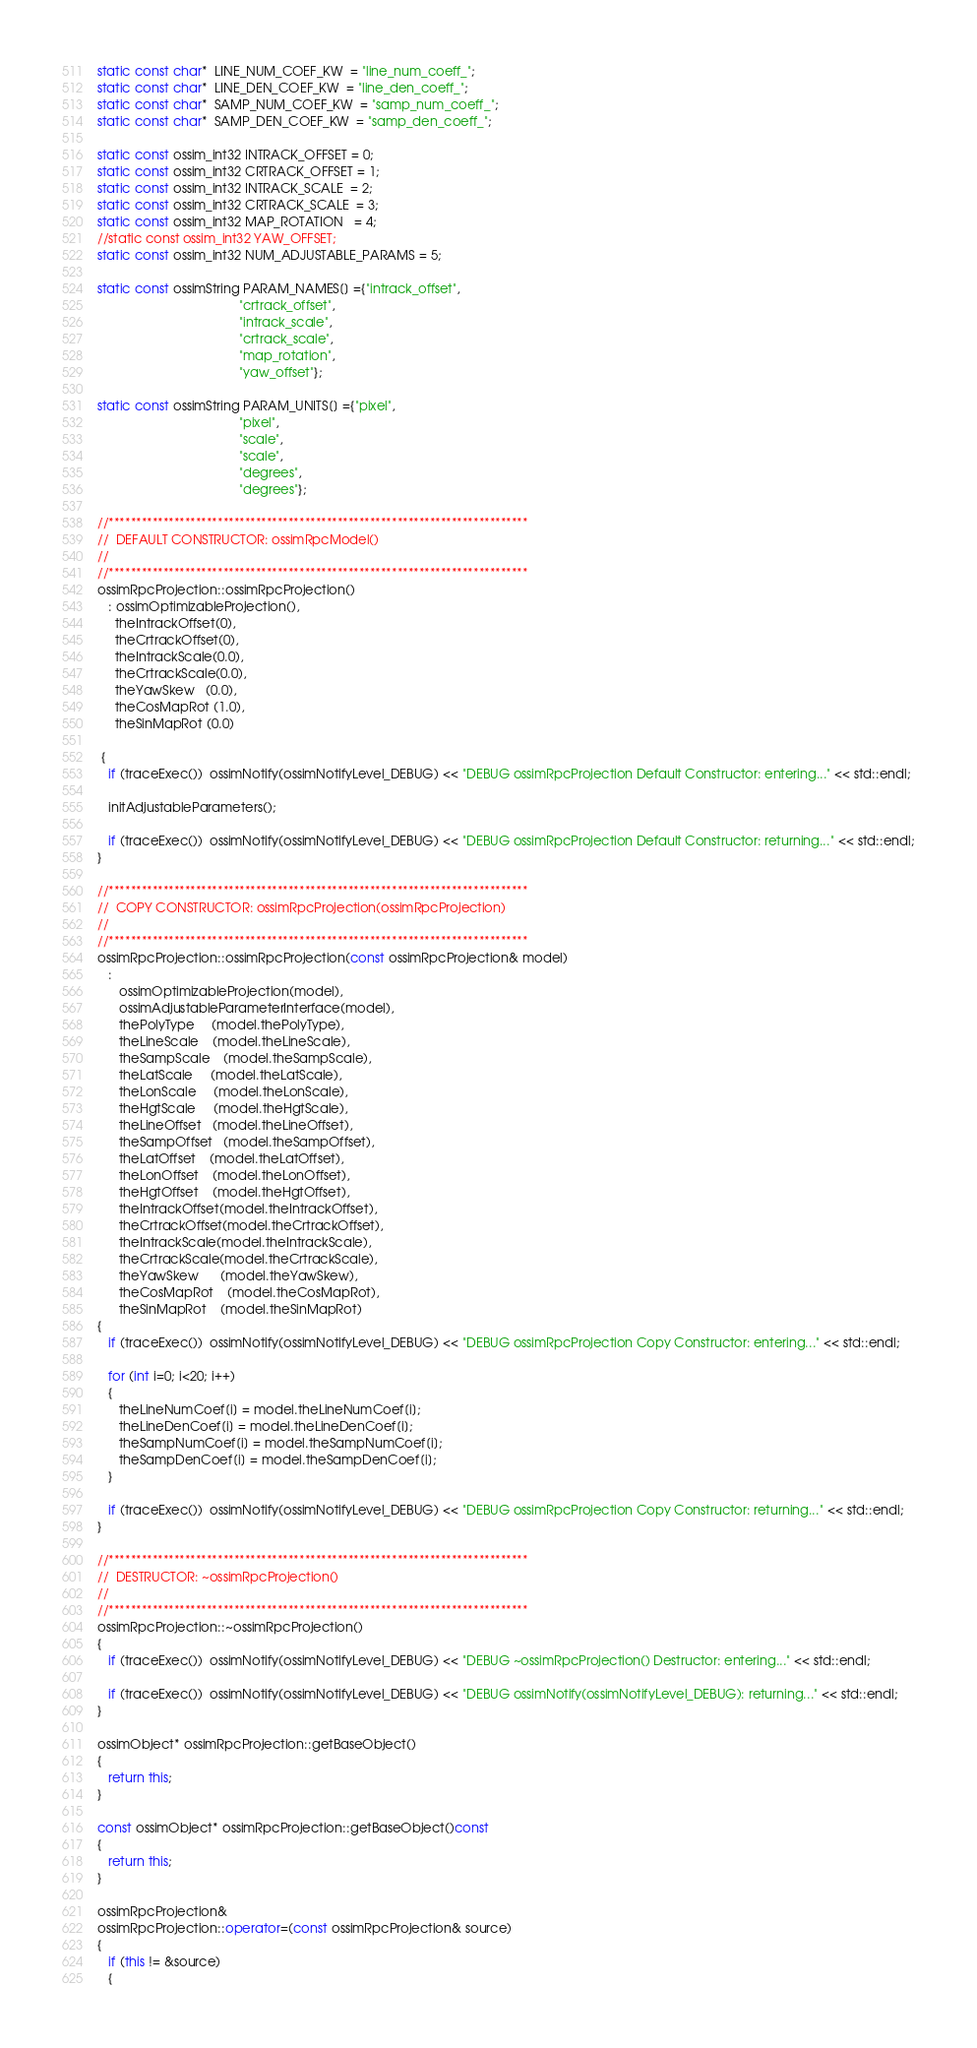Convert code to text. <code><loc_0><loc_0><loc_500><loc_500><_C++_>static const char*  LINE_NUM_COEF_KW  = "line_num_coeff_";
static const char*  LINE_DEN_COEF_KW  = "line_den_coeff_";
static const char*  SAMP_NUM_COEF_KW  = "samp_num_coeff_";
static const char*  SAMP_DEN_COEF_KW  = "samp_den_coeff_";

static const ossim_int32 INTRACK_OFFSET = 0;
static const ossim_int32 CRTRACK_OFFSET = 1;
static const ossim_int32 INTRACK_SCALE  = 2;
static const ossim_int32 CRTRACK_SCALE  = 3;
static const ossim_int32 MAP_ROTATION   = 4;
//static const ossim_int32 YAW_OFFSET;
static const ossim_int32 NUM_ADJUSTABLE_PARAMS = 5;

static const ossimString PARAM_NAMES[] ={"intrack_offset",
                                        "crtrack_offset",
                                        "intrack_scale",
                                        "crtrack_scale",
                                        "map_rotation",
                                        "yaw_offset"};

static const ossimString PARAM_UNITS[] ={"pixel",
                                        "pixel",
                                        "scale",
                                        "scale",
                                        "degrees",
                                        "degrees"};

//*****************************************************************************
//  DEFAULT CONSTRUCTOR: ossimRpcModel()
//  
//*****************************************************************************
ossimRpcProjection::ossimRpcProjection()
   : ossimOptimizableProjection(),
     theIntrackOffset(0),
     theCrtrackOffset(0),
     theIntrackScale(0.0),
     theCrtrackScale(0.0),
     theYawSkew   (0.0),
     theCosMapRot (1.0),
     theSinMapRot (0.0)

 {
   if (traceExec())  ossimNotify(ossimNotifyLevel_DEBUG) << "DEBUG ossimRpcProjection Default Constructor: entering..." << std::endl;

   initAdjustableParameters();
   
   if (traceExec())  ossimNotify(ossimNotifyLevel_DEBUG) << "DEBUG ossimRpcProjection Default Constructor: returning..." << std::endl;
}

//*****************************************************************************
//  COPY CONSTRUCTOR: ossimRpcProjection(ossimRpcProjection)
//  
//*****************************************************************************
ossimRpcProjection::ossimRpcProjection(const ossimRpcProjection& model)
   :
      ossimOptimizableProjection(model),
      ossimAdjustableParameterInterface(model),
      thePolyType     (model.thePolyType),
      theLineScale    (model.theLineScale),
      theSampScale    (model.theSampScale),
      theLatScale     (model.theLatScale),
      theLonScale     (model.theLonScale),
      theHgtScale     (model.theHgtScale),
      theLineOffset   (model.theLineOffset),
      theSampOffset   (model.theSampOffset),
      theLatOffset    (model.theLatOffset),
      theLonOffset    (model.theLonOffset),
      theHgtOffset    (model.theHgtOffset),
      theIntrackOffset(model.theIntrackOffset),
      theCrtrackOffset(model.theCrtrackOffset),
      theIntrackScale(model.theIntrackScale),
      theCrtrackScale(model.theCrtrackScale),
      theYawSkew      (model.theYawSkew),
      theCosMapRot    (model.theCosMapRot),
      theSinMapRot    (model.theSinMapRot)
{
   if (traceExec())  ossimNotify(ossimNotifyLevel_DEBUG) << "DEBUG ossimRpcProjection Copy Constructor: entering..." << std::endl;

   for (int i=0; i<20; i++)
   {
      theLineNumCoef[i] = model.theLineNumCoef[i];
      theLineDenCoef[i] = model.theLineDenCoef[i];
      theSampNumCoef[i] = model.theSampNumCoef[i];
      theSampDenCoef[i] = model.theSampDenCoef[i];
   }
   
   if (traceExec())  ossimNotify(ossimNotifyLevel_DEBUG) << "DEBUG ossimRpcProjection Copy Constructor: returning..." << std::endl;
}

//*****************************************************************************
//  DESTRUCTOR: ~ossimRpcProjection()
//  
//*****************************************************************************
ossimRpcProjection::~ossimRpcProjection()
{
   if (traceExec())  ossimNotify(ossimNotifyLevel_DEBUG) << "DEBUG ~ossimRpcProjection() Destructor: entering..." << std::endl;
   
   if (traceExec())  ossimNotify(ossimNotifyLevel_DEBUG) << "DEBUG ossimNotify(ossimNotifyLevel_DEBUG): returning..." << std::endl;
}

ossimObject* ossimRpcProjection::getBaseObject()
{
   return this;
}

const ossimObject* ossimRpcProjection::getBaseObject()const
{
   return this;
}

ossimRpcProjection& 
ossimRpcProjection::operator=(const ossimRpcProjection& source)
{
   if (this != &source)
   {</code> 